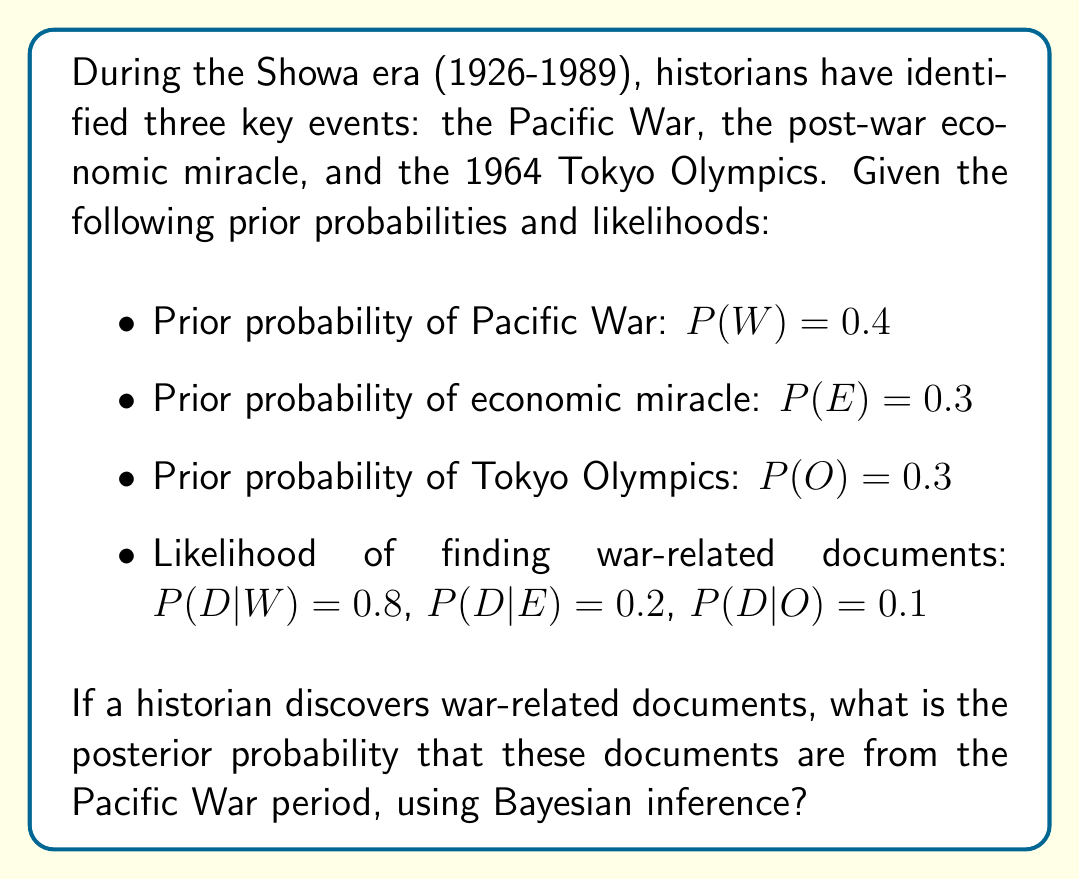What is the answer to this math problem? To solve this problem, we'll use Bayes' theorem:

$$P(W|D) = \frac{P(D|W) \cdot P(W)}{P(D)}$$

Where:
- $P(W|D)$ is the posterior probability of the Pacific War given the discovery of war-related documents
- $P(D|W)$ is the likelihood of finding war-related documents given that it's from the Pacific War period
- $P(W)$ is the prior probability of the Pacific War
- $P(D)$ is the total probability of finding war-related documents

Step 1: We have $P(D|W)$, $P(W)$, but we need to calculate $P(D)$.

Step 2: Calculate $P(D)$ using the law of total probability:
$$P(D) = P(D|W) \cdot P(W) + P(D|E) \cdot P(E) + P(D|O) \cdot P(O)$$
$$P(D) = 0.8 \cdot 0.4 + 0.2 \cdot 0.3 + 0.1 \cdot 0.3 = 0.32 + 0.06 + 0.03 = 0.41$$

Step 3: Now we can apply Bayes' theorem:

$$P(W|D) = \frac{0.8 \cdot 0.4}{0.41} = \frac{0.32}{0.41} \approx 0.7805$$

Therefore, the posterior probability that the war-related documents are from the Pacific War period is approximately 0.7805 or 78.05%.
Answer: 0.7805 